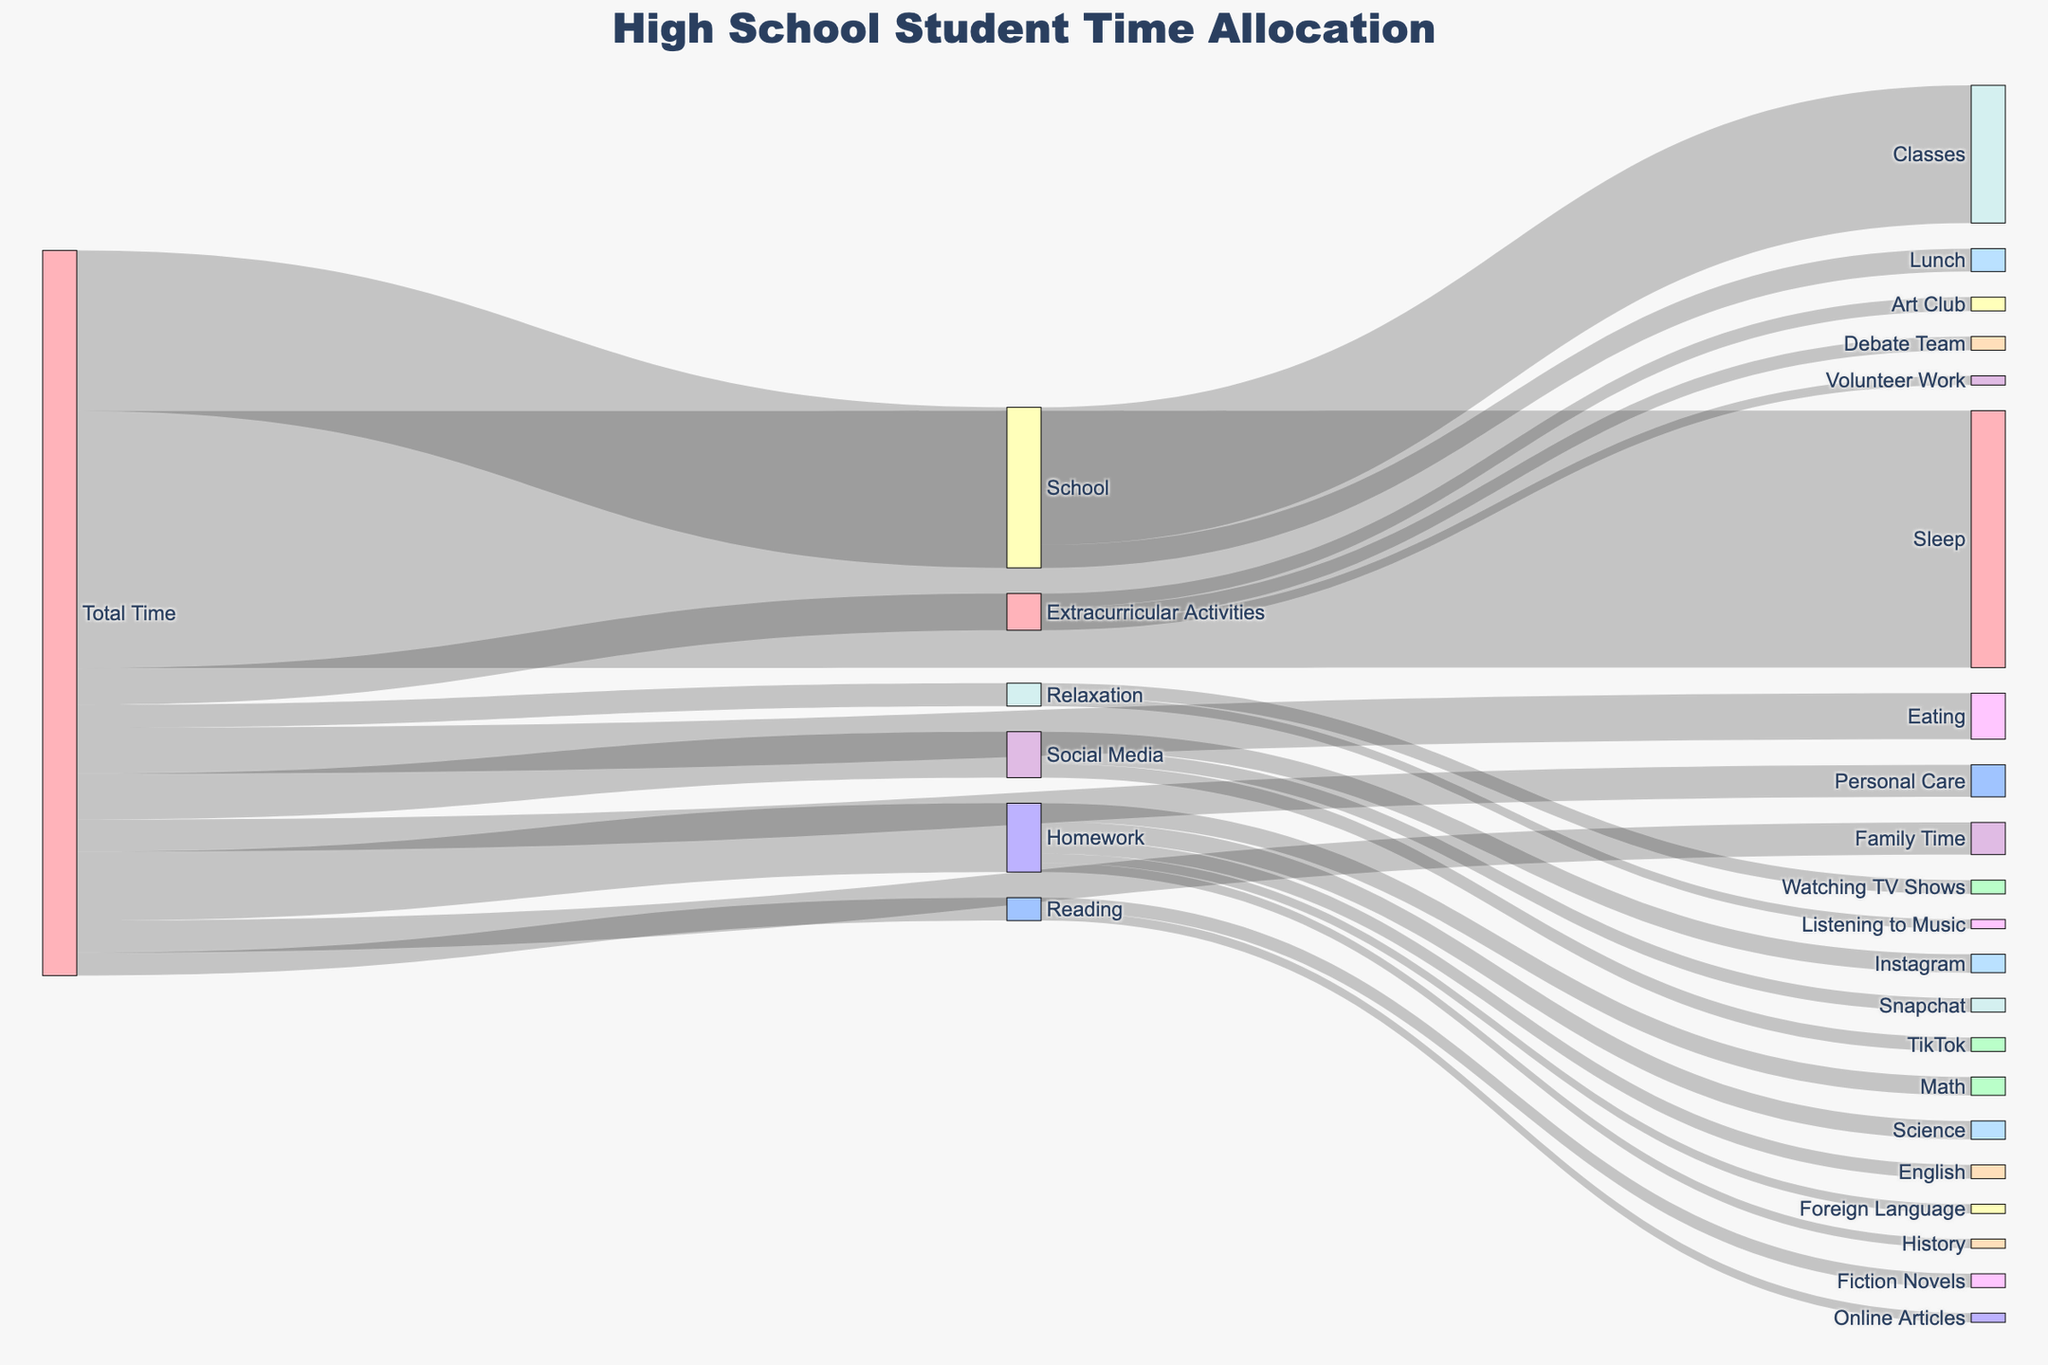What are the top three activities high school students spend the most time on? To determine the top three activities, we look at the connections from "Total Time" to various activities. School has 35 hours, Sleep has 56 hours, and Homework has 15 hours. These are the highest values.
Answer: Sleep, School, Homework How much time is allocated to Social Media in a typical week? From "Total Time," we see Social Media has a value of 10 hours.
Answer: 10 hours Which extracurricular activity has the most hours allocated? From "Extracurricular Activities," we compare the values for Art Club, Debate Team, and Volunteer Work. Both Art Club and Debate Team have 3 hours each, while Volunteer Work has 2 hours.
Answer: Art Club and Debate Team What is the total amount of time spent on relaxation activities? From "Relaxation," we sum the values for Listening to Music and Watching TV Shows. Listening to Music has 2 hours, and Watching TV Shows has 3 hours. So, 2 + 3 = 5 hours.
Answer: 5 hours How does the time spent on Personal Care compare to the time spent on Family Time? The "Total Time" connections show Personal Care with 7 hours and Family Time with 7 hours as well. These values are equal.
Answer: Equal What percentage of total time is spent on School? Total time for all activities is the sum of all values from "Total Time," which is 35 + 56 + 15 + 10 + 5 + 7 + 10 + 7 + 8 + 5 = 158 hours. The time spent on School is 35 hours. The percentage is (35 / 158) * 100, which is approximately 22.15%.
Answer: 22.15% How much time do students spend on academic activities including School and Homework? The time for School is 35 hours, and the time for Homework is 15 hours. The total time on academic activities is 35 + 15 = 50 hours.
Answer: 50 hours What is the least time-consuming category among the listed activities from "Total Time"? By comparing all the target activities from "Total Time," the lowest value is for Reading and Relaxation, both at 5 hours.
Answer: Reading and Relaxation How many hours are spent on Math Homework out of the total Homework time? From "Homework," Math Homework is shown to take 4 hours. The total Homework time is 15 hours. Therefore, 4 out of 15 hours are spent on Math Homework.
Answer: 4 hours 